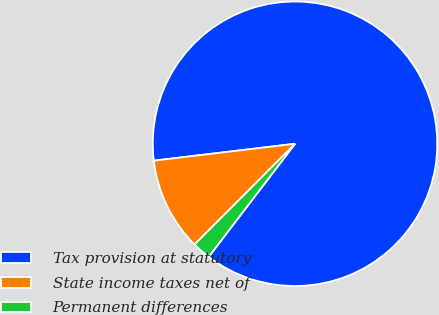Convert chart. <chart><loc_0><loc_0><loc_500><loc_500><pie_chart><fcel>Tax provision at statutory<fcel>State income taxes net of<fcel>Permanent differences<nl><fcel>87.28%<fcel>10.62%<fcel>2.1%<nl></chart> 